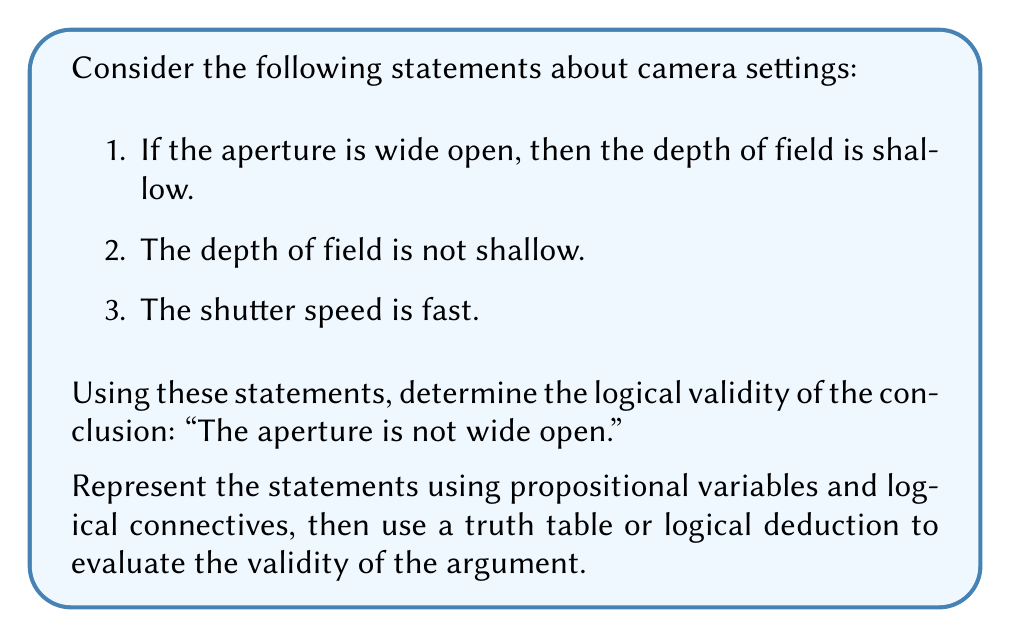Could you help me with this problem? Let's approach this step-by-step:

1) First, let's define our propositional variables:
   $A$: The aperture is wide open
   $D$: The depth of field is shallow
   $S$: The shutter speed is fast

2) Now, we can represent our statements using logical connectives:
   Statement 1: $A \rightarrow D$ (If A, then D)
   Statement 2: $\neg D$ (Not D)
   Statement 3: $S$ (S is true, but it's not relevant to our conclusion)
   Conclusion: $\neg A$ (Not A)

3) Our argument structure is:
   $$ \frac{A \rightarrow D, \quad \neg D}{
   \therefore \neg A} $$

4) This is a valid argument form known as Modus Tollens (denying the consequent).

5) We can verify this using a truth table:

   $$
   \begin{array}{|c|c|c|c|c|}
   \hline
   A & D & A \rightarrow D & \neg D & \neg A \\
   \hline
   T & T & T & F & F \\
   T & F & F & T & F \\
   F & T & T & F & T \\
   F & F & T & T & T \\
   \hline
   \end{array}
   $$

6) From the truth table, we can see that whenever $(A \rightarrow D)$ and $\neg D$ are both true (last row), $\neg A$ is also true.

7) Therefore, the conclusion "The aperture is not wide open" logically follows from the given premises, regardless of the truth value of the statement about shutter speed.

This logical structure is particularly relevant for a photographer, as it demonstrates how knowledge about depth of field can inform conclusions about aperture settings, which is crucial for achieving desired effects in both vintage and modern photography.
Answer: The conclusion "The aperture is not wide open" is logically valid based on the given statements. 